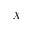Convert formula to latex. <formula><loc_0><loc_0><loc_500><loc_500>X</formula> 